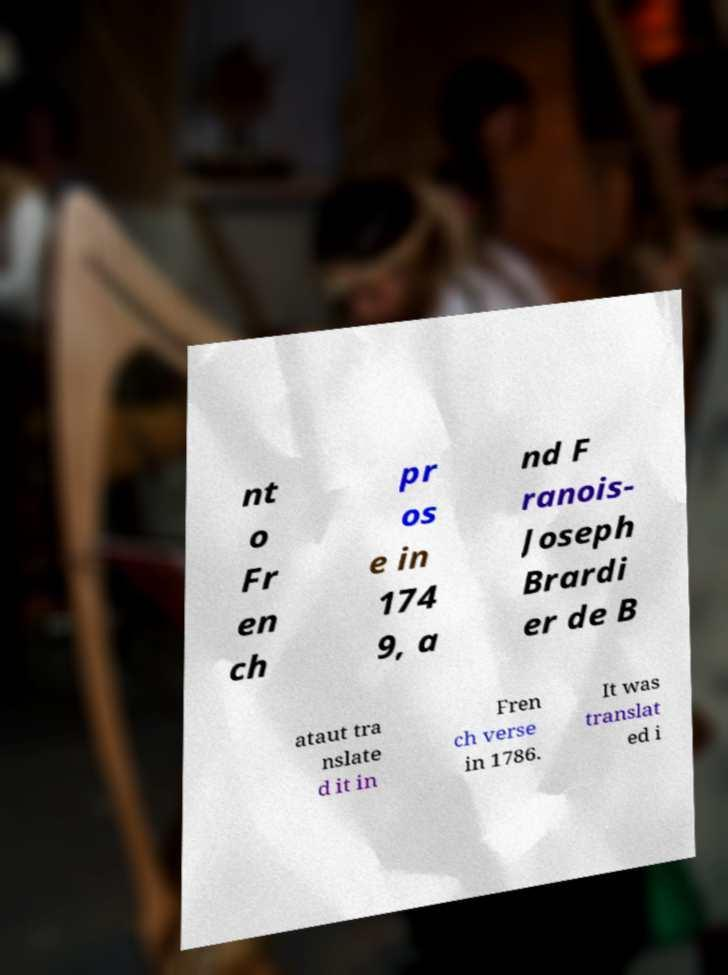What messages or text are displayed in this image? I need them in a readable, typed format. nt o Fr en ch pr os e in 174 9, a nd F ranois- Joseph Brardi er de B ataut tra nslate d it in Fren ch verse in 1786. It was translat ed i 